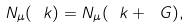Convert formula to latex. <formula><loc_0><loc_0><loc_500><loc_500>N _ { \mu } ( \ k ) = N _ { \mu } ( \ k + \ G ) ,</formula> 